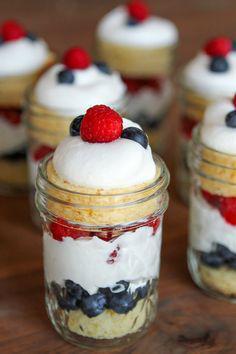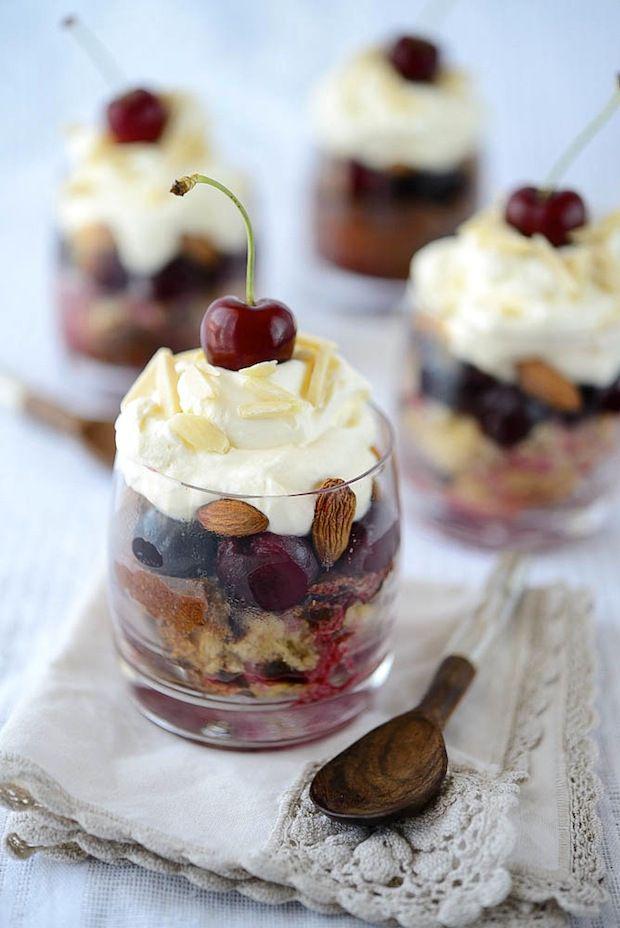The first image is the image on the left, the second image is the image on the right. Analyze the images presented: Is the assertion "All of the desserts shown have some type of fruit on top." valid? Answer yes or no. Yes. The first image is the image on the left, the second image is the image on the right. Considering the images on both sides, is "There are four glasses of a whipped cream topped dessert in one of the images." valid? Answer yes or no. Yes. 